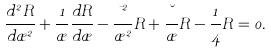<formula> <loc_0><loc_0><loc_500><loc_500>\frac { d ^ { 2 } R } { d \rho ^ { 2 } } + \frac { 1 } { \rho } \frac { d R } { d \rho } - \frac { \mu ^ { 2 } } { \rho ^ { 2 } } R + \frac { \lambda } { \rho } R - \frac { 1 } { 4 } R = 0 .</formula> 